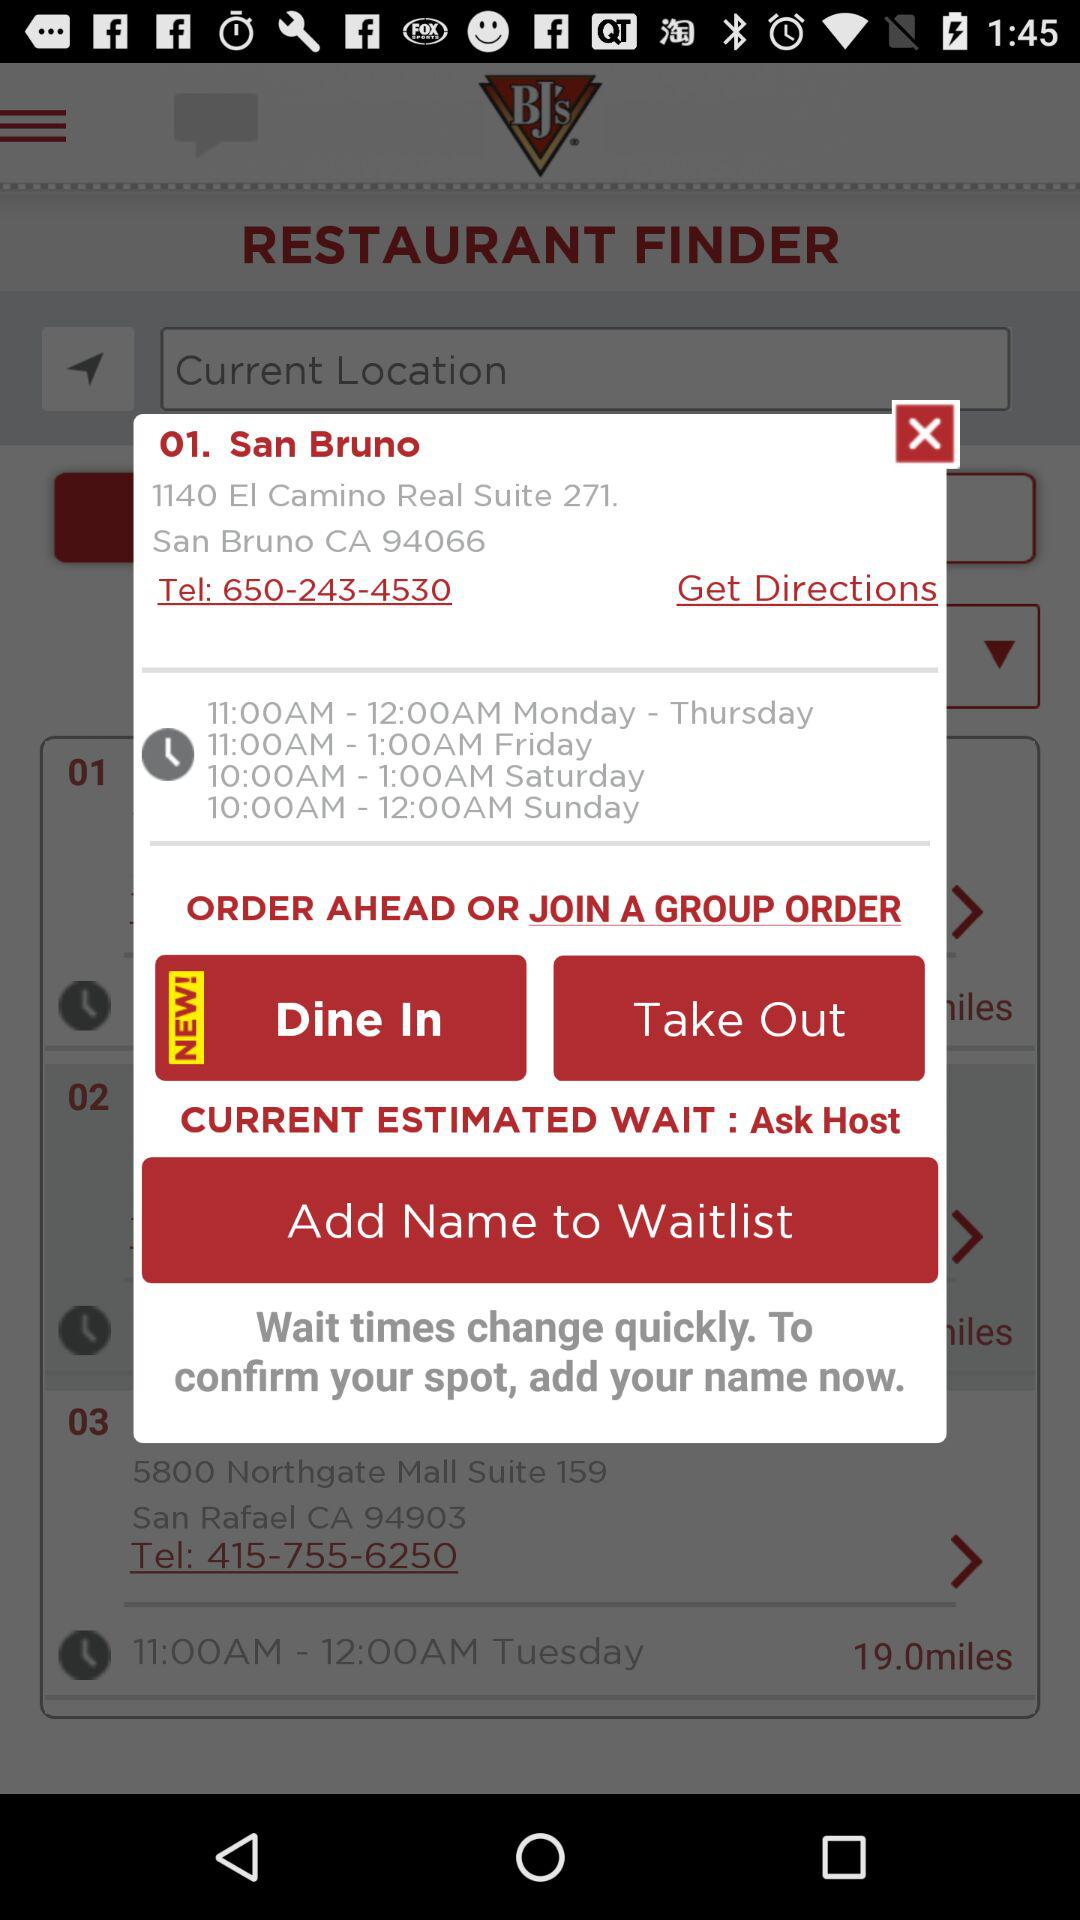What is the timing from Monday to Thursday? The timing from Monday to Thursday is 11 a.m. to 12 a.m. 